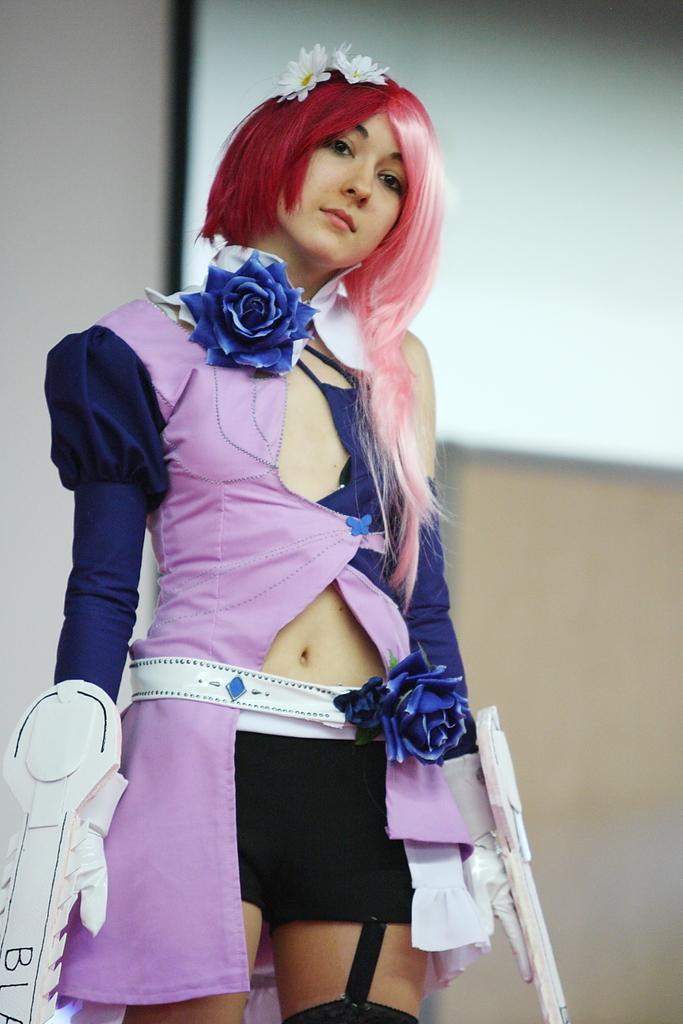Can you describe this image briefly? In the picture I can see a woman is standing. The woman is wearing clothes and some other objects. In the background I can see a white color board attached to a wall. The background of the image is blurred. 